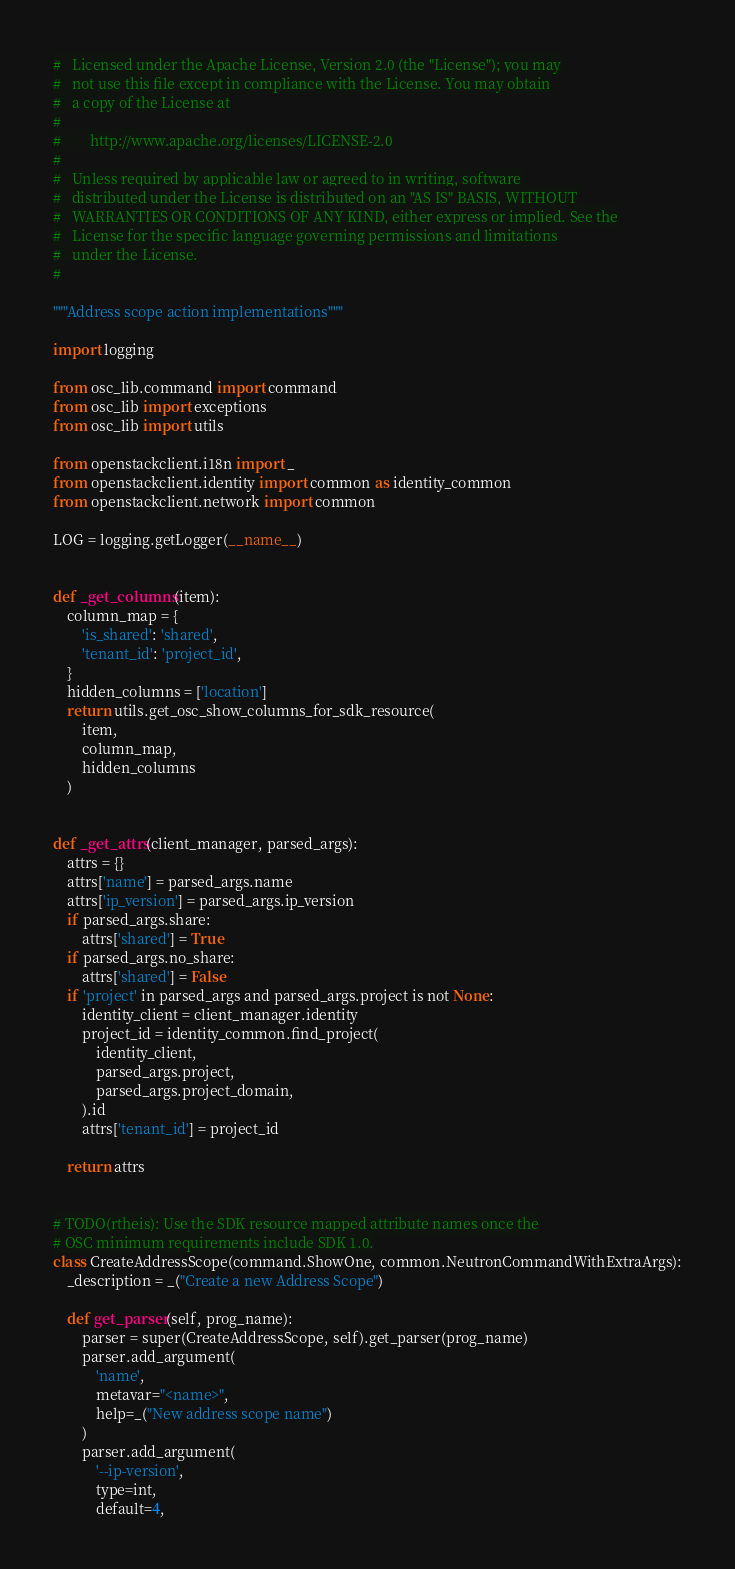Convert code to text. <code><loc_0><loc_0><loc_500><loc_500><_Python_>#   Licensed under the Apache License, Version 2.0 (the "License"); you may
#   not use this file except in compliance with the License. You may obtain
#   a copy of the License at
#
#        http://www.apache.org/licenses/LICENSE-2.0
#
#   Unless required by applicable law or agreed to in writing, software
#   distributed under the License is distributed on an "AS IS" BASIS, WITHOUT
#   WARRANTIES OR CONDITIONS OF ANY KIND, either express or implied. See the
#   License for the specific language governing permissions and limitations
#   under the License.
#

"""Address scope action implementations"""

import logging

from osc_lib.command import command
from osc_lib import exceptions
from osc_lib import utils

from openstackclient.i18n import _
from openstackclient.identity import common as identity_common
from openstackclient.network import common

LOG = logging.getLogger(__name__)


def _get_columns(item):
    column_map = {
        'is_shared': 'shared',
        'tenant_id': 'project_id',
    }
    hidden_columns = ['location']
    return utils.get_osc_show_columns_for_sdk_resource(
        item,
        column_map,
        hidden_columns
    )


def _get_attrs(client_manager, parsed_args):
    attrs = {}
    attrs['name'] = parsed_args.name
    attrs['ip_version'] = parsed_args.ip_version
    if parsed_args.share:
        attrs['shared'] = True
    if parsed_args.no_share:
        attrs['shared'] = False
    if 'project' in parsed_args and parsed_args.project is not None:
        identity_client = client_manager.identity
        project_id = identity_common.find_project(
            identity_client,
            parsed_args.project,
            parsed_args.project_domain,
        ).id
        attrs['tenant_id'] = project_id

    return attrs


# TODO(rtheis): Use the SDK resource mapped attribute names once the
# OSC minimum requirements include SDK 1.0.
class CreateAddressScope(command.ShowOne, common.NeutronCommandWithExtraArgs):
    _description = _("Create a new Address Scope")

    def get_parser(self, prog_name):
        parser = super(CreateAddressScope, self).get_parser(prog_name)
        parser.add_argument(
            'name',
            metavar="<name>",
            help=_("New address scope name")
        )
        parser.add_argument(
            '--ip-version',
            type=int,
            default=4,</code> 